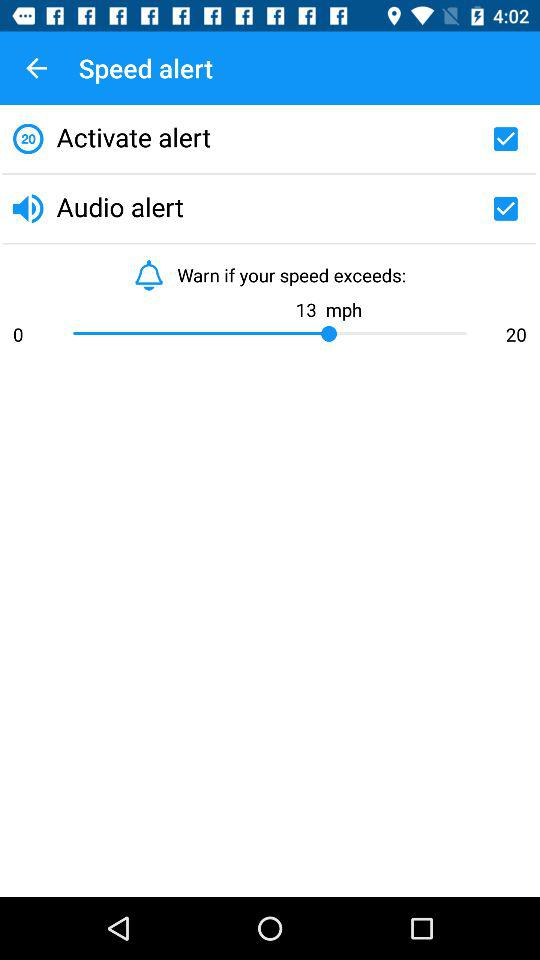What is the current status of "Audio alert"? The current status of "Audio alert" is "on". 